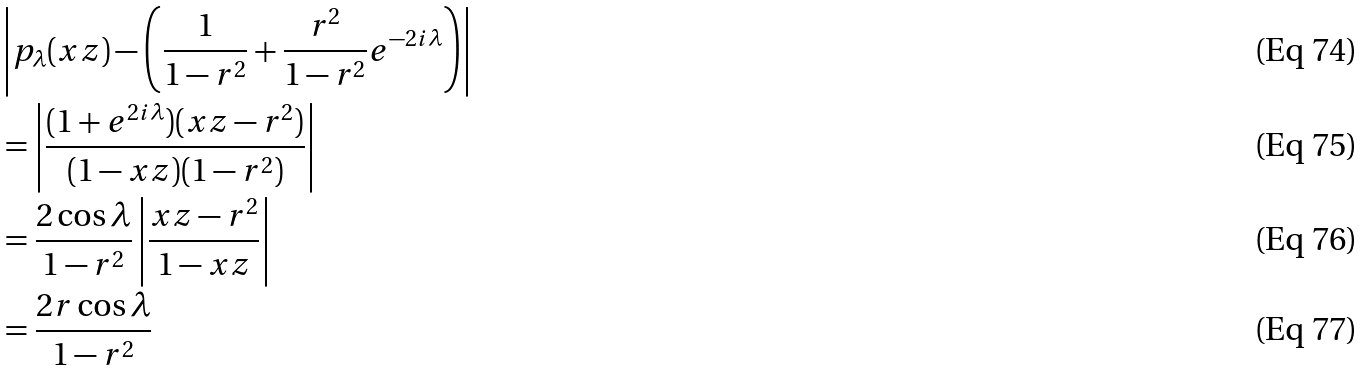<formula> <loc_0><loc_0><loc_500><loc_500>& \left | p _ { \lambda } ( x z ) - \left ( \frac { 1 } { 1 - r ^ { 2 } } + \frac { r ^ { 2 } } { 1 - r ^ { 2 } } e ^ { - 2 i \lambda } \right ) \right | \\ & = \left | \frac { ( 1 + e ^ { 2 i \lambda } ) ( x z - r ^ { 2 } ) } { ( 1 - x z ) ( 1 - r ^ { 2 } ) } \right | \\ & = \frac { 2 \cos \lambda } { 1 - r ^ { 2 } } \left | \frac { x z - r ^ { 2 } } { 1 - x z } \right | \\ & = \frac { 2 r \cos \lambda } { 1 - r ^ { 2 } }</formula> 